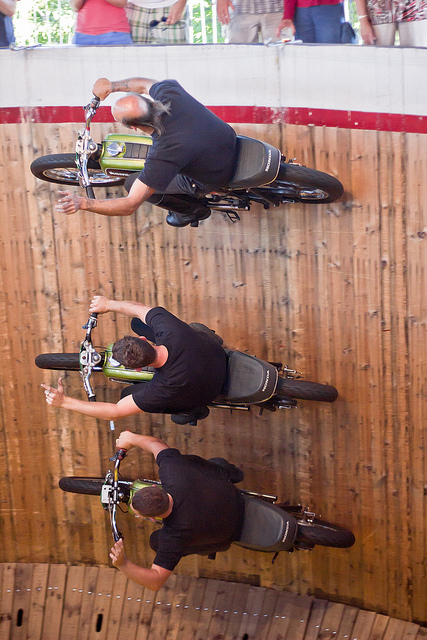<image>Who is the oldest of the three men? I don't know who the oldest man is. The answer could be either the man on top with balding hair, the man on the far right, or the bald man. Who is the oldest of the three men? I don't know who the oldest of the three men is. 